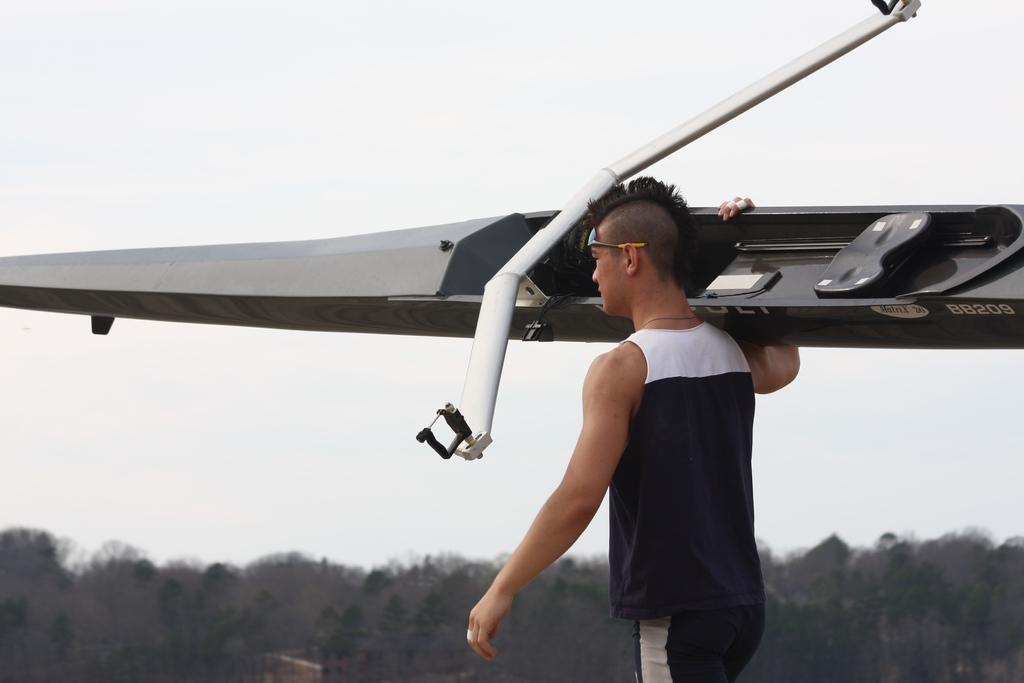What is the letters and numbers on the board / boat there?
Make the answer very short. 88209. 